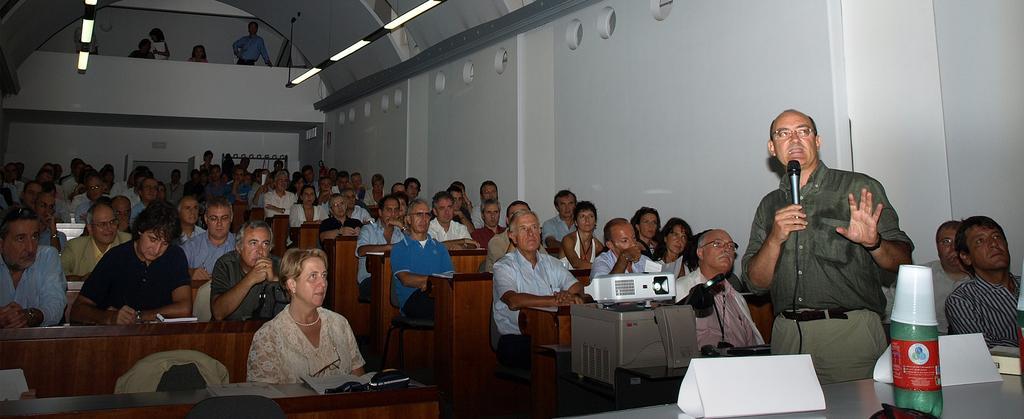How would you summarize this image in a sentence or two? A group of people sitting on a chair. In-front of this person there are tables, on this table there is a book, projector, bottle and cup. This man is holding a mic and wore spectacles. Far on top this persons are standing. A jacket on chair. 